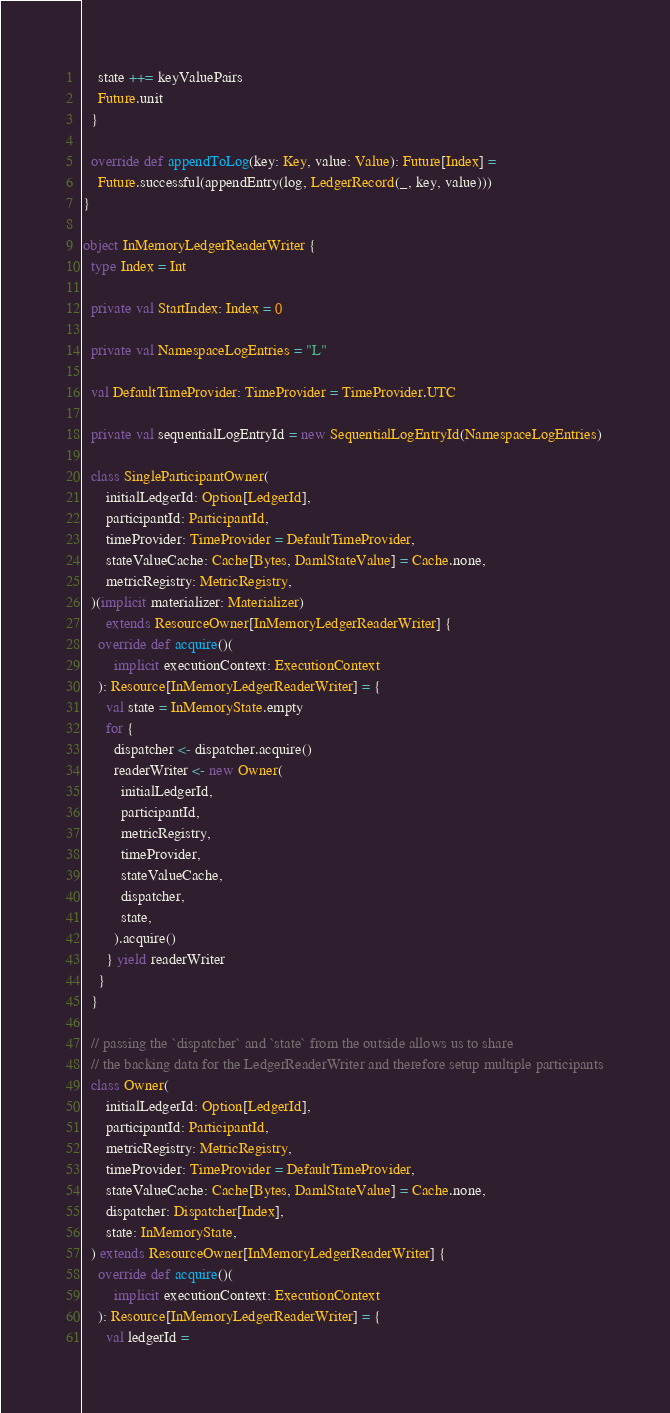<code> <loc_0><loc_0><loc_500><loc_500><_Scala_>    state ++= keyValuePairs
    Future.unit
  }

  override def appendToLog(key: Key, value: Value): Future[Index] =
    Future.successful(appendEntry(log, LedgerRecord(_, key, value)))
}

object InMemoryLedgerReaderWriter {
  type Index = Int

  private val StartIndex: Index = 0

  private val NamespaceLogEntries = "L"

  val DefaultTimeProvider: TimeProvider = TimeProvider.UTC

  private val sequentialLogEntryId = new SequentialLogEntryId(NamespaceLogEntries)

  class SingleParticipantOwner(
      initialLedgerId: Option[LedgerId],
      participantId: ParticipantId,
      timeProvider: TimeProvider = DefaultTimeProvider,
      stateValueCache: Cache[Bytes, DamlStateValue] = Cache.none,
      metricRegistry: MetricRegistry,
  )(implicit materializer: Materializer)
      extends ResourceOwner[InMemoryLedgerReaderWriter] {
    override def acquire()(
        implicit executionContext: ExecutionContext
    ): Resource[InMemoryLedgerReaderWriter] = {
      val state = InMemoryState.empty
      for {
        dispatcher <- dispatcher.acquire()
        readerWriter <- new Owner(
          initialLedgerId,
          participantId,
          metricRegistry,
          timeProvider,
          stateValueCache,
          dispatcher,
          state,
        ).acquire()
      } yield readerWriter
    }
  }

  // passing the `dispatcher` and `state` from the outside allows us to share
  // the backing data for the LedgerReaderWriter and therefore setup multiple participants
  class Owner(
      initialLedgerId: Option[LedgerId],
      participantId: ParticipantId,
      metricRegistry: MetricRegistry,
      timeProvider: TimeProvider = DefaultTimeProvider,
      stateValueCache: Cache[Bytes, DamlStateValue] = Cache.none,
      dispatcher: Dispatcher[Index],
      state: InMemoryState,
  ) extends ResourceOwner[InMemoryLedgerReaderWriter] {
    override def acquire()(
        implicit executionContext: ExecutionContext
    ): Resource[InMemoryLedgerReaderWriter] = {
      val ledgerId =</code> 